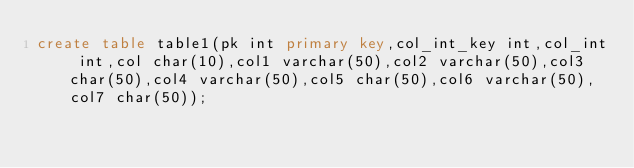<code> <loc_0><loc_0><loc_500><loc_500><_SQL_>create table table1(pk int primary key,col_int_key int,col_int int,col char(10),col1 varchar(50),col2 varchar(50),col3 char(50),col4 varchar(50),col5 char(50),col6 varchar(50),col7 char(50));</code> 